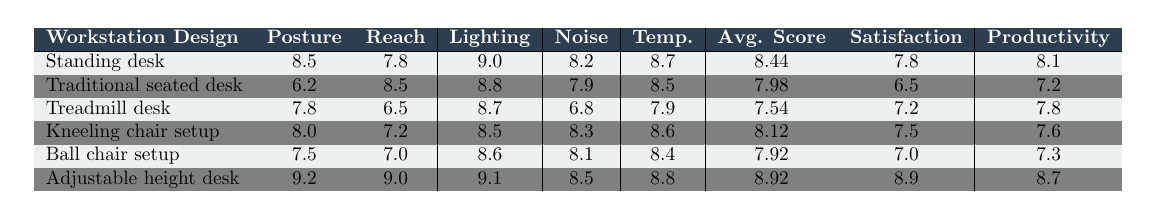What is the ergonomic assessment score for the Standing desk in terms of Posture? The table shows the score for Posture under the Standing desk category, which is directly listed as 8.5.
Answer: 8.5 Which workstation design has the highest score for Lighting? By comparing the Lighting scores across all workstation designs, the highest score is 9.1, corresponding to the Adjustable height desk.
Answer: Adjustable height desk What is the average ergonomic score for the Traditional seated desk? The average ergonomic score is calculated as (6.2 + 8.5 + 8.8 + 7.9 + 8.5) / 5 = 7.98.
Answer: 7.98 Is the employee satisfaction score for the Treadmill desk higher than that of the Ball chair setup? The employee satisfaction score for the Treadmill desk is 7.2, while for the Ball chair setup it is 7.0. Since 7.2 is greater than 7.0, the statement is true.
Answer: Yes Which workstation design has both the lowest Posture score and the highest Reach score? The Traditional seated desk has the lowest Posture score of 6.2 and the same workstation design has a Reach score of 8.5, which is the highest of all the designs.
Answer: Traditional seated desk Calculate the difference in average ergonomic scores between the Standing desk and the Adjustable height desk. The average scores are 8.44 for the Standing desk and 8.92 for the Adjustable height desk. The difference is 8.92 - 8.44 = 0.48.
Answer: 0.48 Which ergonomic factor contributes the most to the average score of the Kneeling chair setup? The scores for the Kneeling chair setup show Posture (8.0), Reach (7.2), Lighting (8.5), Noise (8.3), and Temperature (8.6). Lighting has the highest score of 8.5, making it the most contributing factor.
Answer: Lighting What is the productivity index for the workstation design with the highest ergonomic score? The Adjustable height desk has the highest ergonomic score of 8.92 and its corresponding productivity index is 8.7.
Answer: 8.7 Which workstation design has the lowest temperature score? Looking at the temperature scores, the Treadmill desk has the lowest score of 7.9.
Answer: Treadmill desk If a user has to choose between the Traditional seated desk and the Kneeling chair setup based on employee satisfaction, which one should they choose? The employee satisfaction for the Traditional seated desk is 6.5, while for the Kneeling chair setup it is 7.5, indicating the latter is a better choice for user satisfaction.
Answer: Kneeling chair setup 